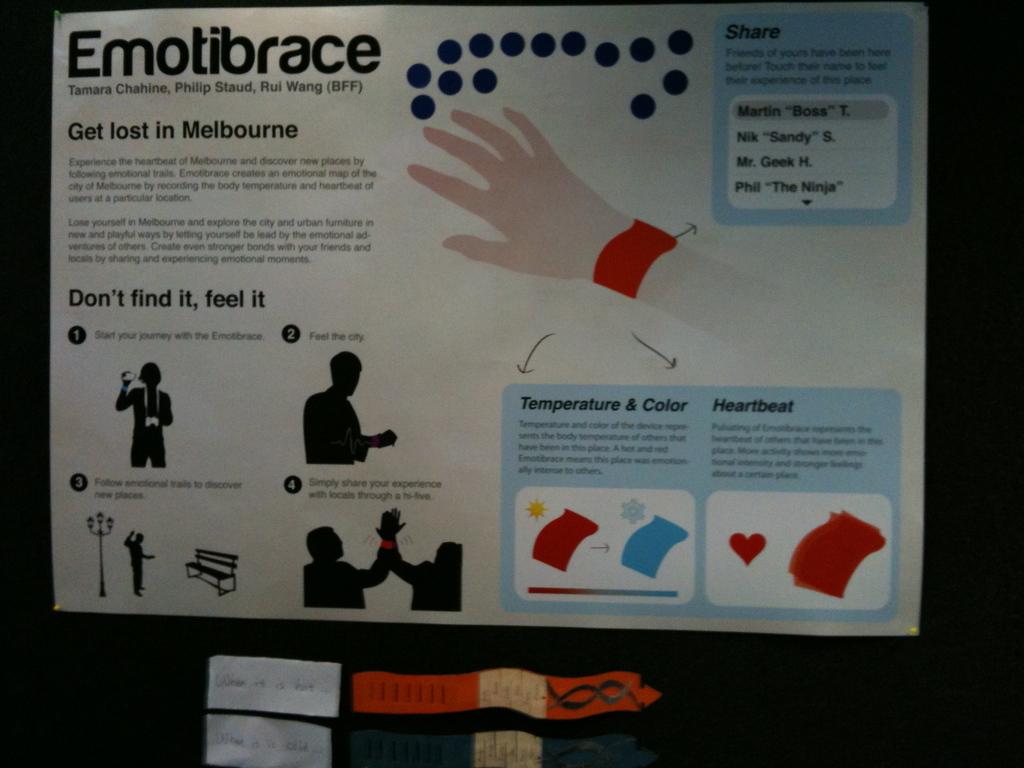Who made this poster?
Your answer should be very brief. Emotibrace. Where can you get lost?
Your response must be concise. Melbourne. 